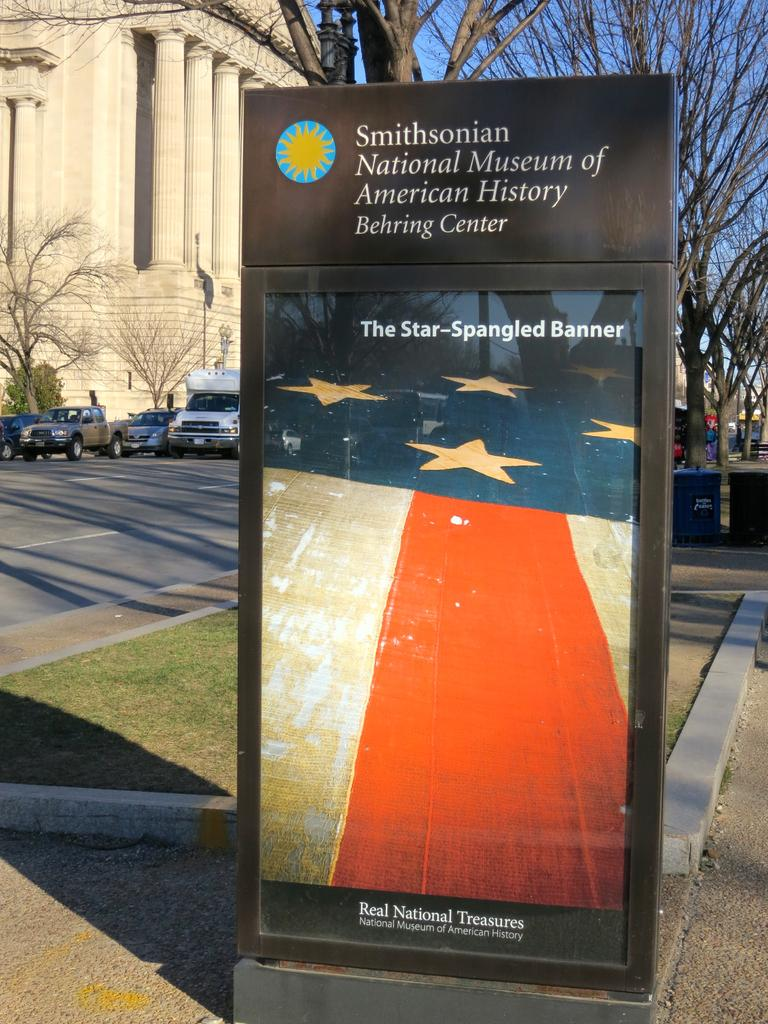<image>
Present a compact description of the photo's key features. A picture of the star spangled banner with a sign of the smithsonian national museum at the top. 